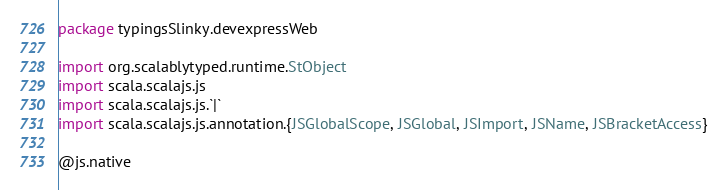Convert code to text. <code><loc_0><loc_0><loc_500><loc_500><_Scala_>package typingsSlinky.devexpressWeb

import org.scalablytyped.runtime.StObject
import scala.scalajs.js
import scala.scalajs.js.`|`
import scala.scalajs.js.annotation.{JSGlobalScope, JSGlobal, JSImport, JSName, JSBracketAccess}

@js.native</code> 